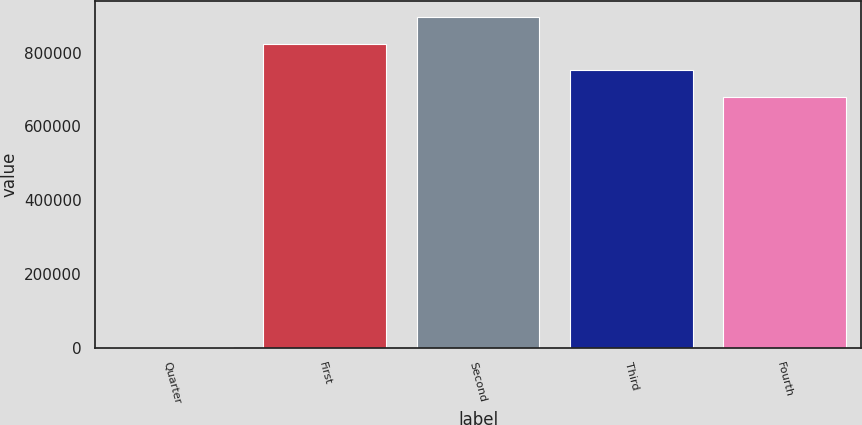<chart> <loc_0><loc_0><loc_500><loc_500><bar_chart><fcel>Quarter<fcel>First<fcel>Second<fcel>Third<fcel>Fourth<nl><fcel>2012<fcel>824419<fcel>896350<fcel>752488<fcel>680558<nl></chart> 